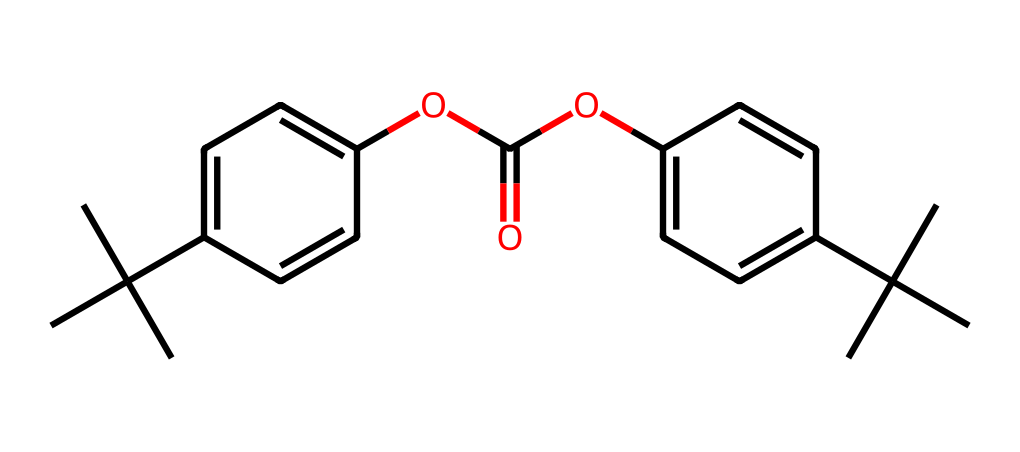What is the main functional group present in this molecule? The molecule contains an ester functional group identified by the -COO- linkage (specifically the -OC(=O)- part). This allows recognition of major functional groups in the structure.
Answer: ester How many aromatic rings are present in this structure? The chemical structure features two distinct aromatic rings, each indicated by their alternating double bonds in the benzene-like structure.
Answer: two What type of intermolecular forces are likely present in this non-electrolyte? Given that this compound is a non-electrolyte with no charged species, the predominant intermolecular forces present are van der Waals forces and dipole-dipole interactions due to polar bonds in the ester group.
Answer: van der Waals forces How many tertiary carbon atoms are in the molecule? The structure features four tertiary carbon atoms, identifiable at the branching points of tert-butyl groups which have three other carbon atoms bonded to them.
Answer: four What is the overall polarity of the molecule given its structure? The structure has a mix of non-polar (aromatic) and polar (ester) regions, but the overall molecule is slightly polar due to the presence of the ester group, which can lead to polar interactions.
Answer: slightly polar What property makes polycarbonate suitable for eyeglass lenses? The polymer structure of polycarbonate gives it high impact resistance and optical clarity, which are essential properties for eyeglass lenses.
Answer: high impact resistance 